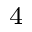Convert formula to latex. <formula><loc_0><loc_0><loc_500><loc_500>_ { 4 }</formula> 